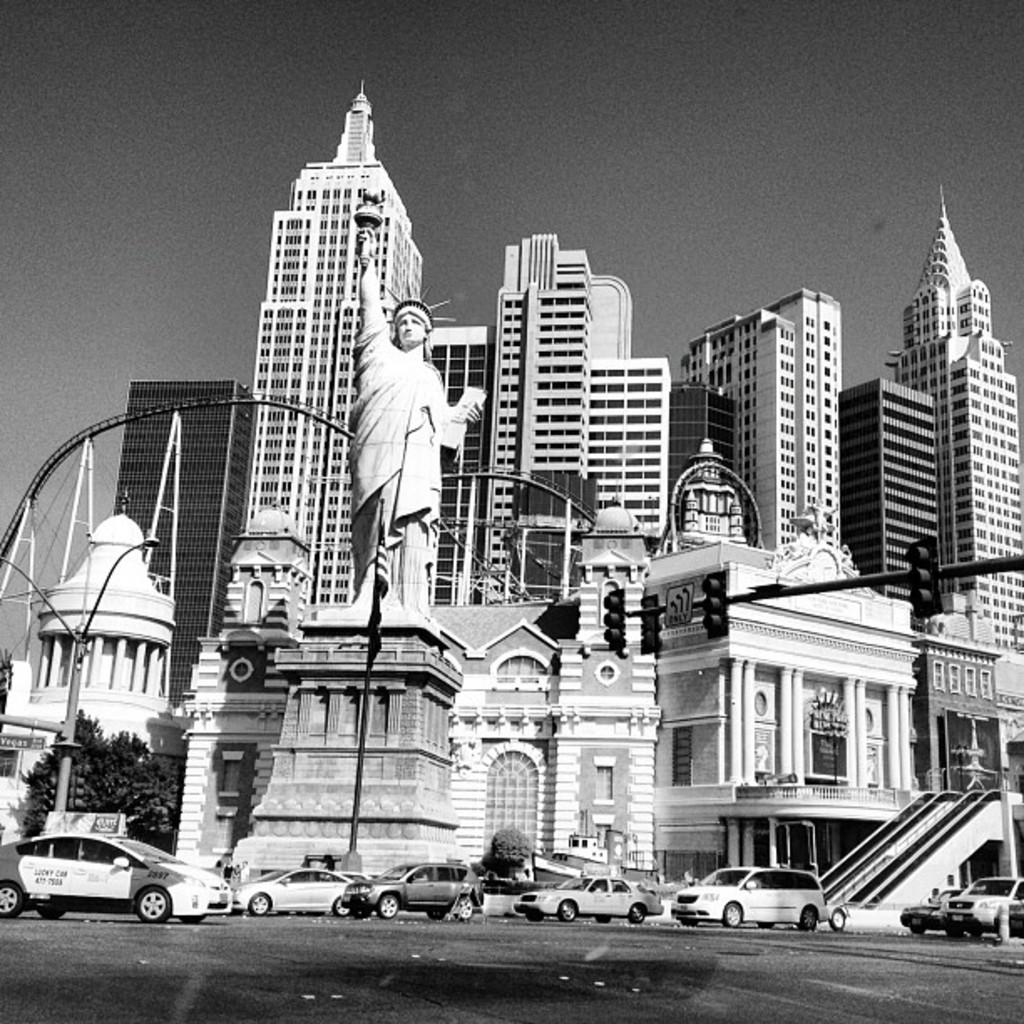What type of structures can be seen in the image? There are many buildings in the image. What is happening on the road in the image? There are vehicles moving on the road in the image. Can you describe any specific object in the image? There is a scepter visible in the image. What helps regulate traffic in the image? There are signal lights in the image. Where is the kitty playing with the donkey in the image? There is no kitty or donkey present in the image. What type of stitch is being used to sew the curtains in the image? There are no curtains or stitching visible in the image. 